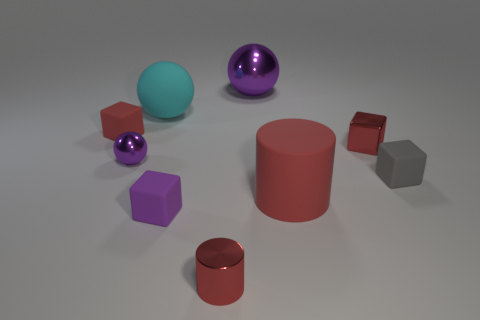Add 1 purple metallic spheres. How many objects exist? 10 Subtract all tiny gray blocks. How many blocks are left? 3 Subtract 1 cylinders. How many cylinders are left? 1 Subtract all brown spheres. Subtract all red blocks. How many spheres are left? 3 Subtract all cyan cylinders. How many green balls are left? 0 Subtract all rubber things. Subtract all small metallic things. How many objects are left? 1 Add 6 red matte cylinders. How many red matte cylinders are left? 7 Add 4 tiny things. How many tiny things exist? 10 Subtract all purple spheres. How many spheres are left? 1 Subtract 1 cyan spheres. How many objects are left? 8 